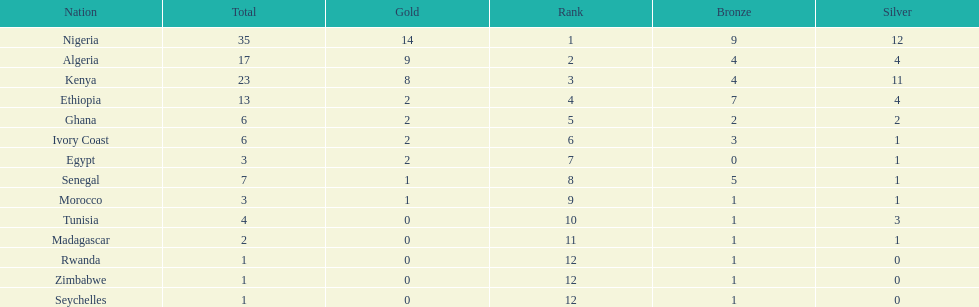What is the name of the only nation that did not earn any bronze medals? Egypt. 